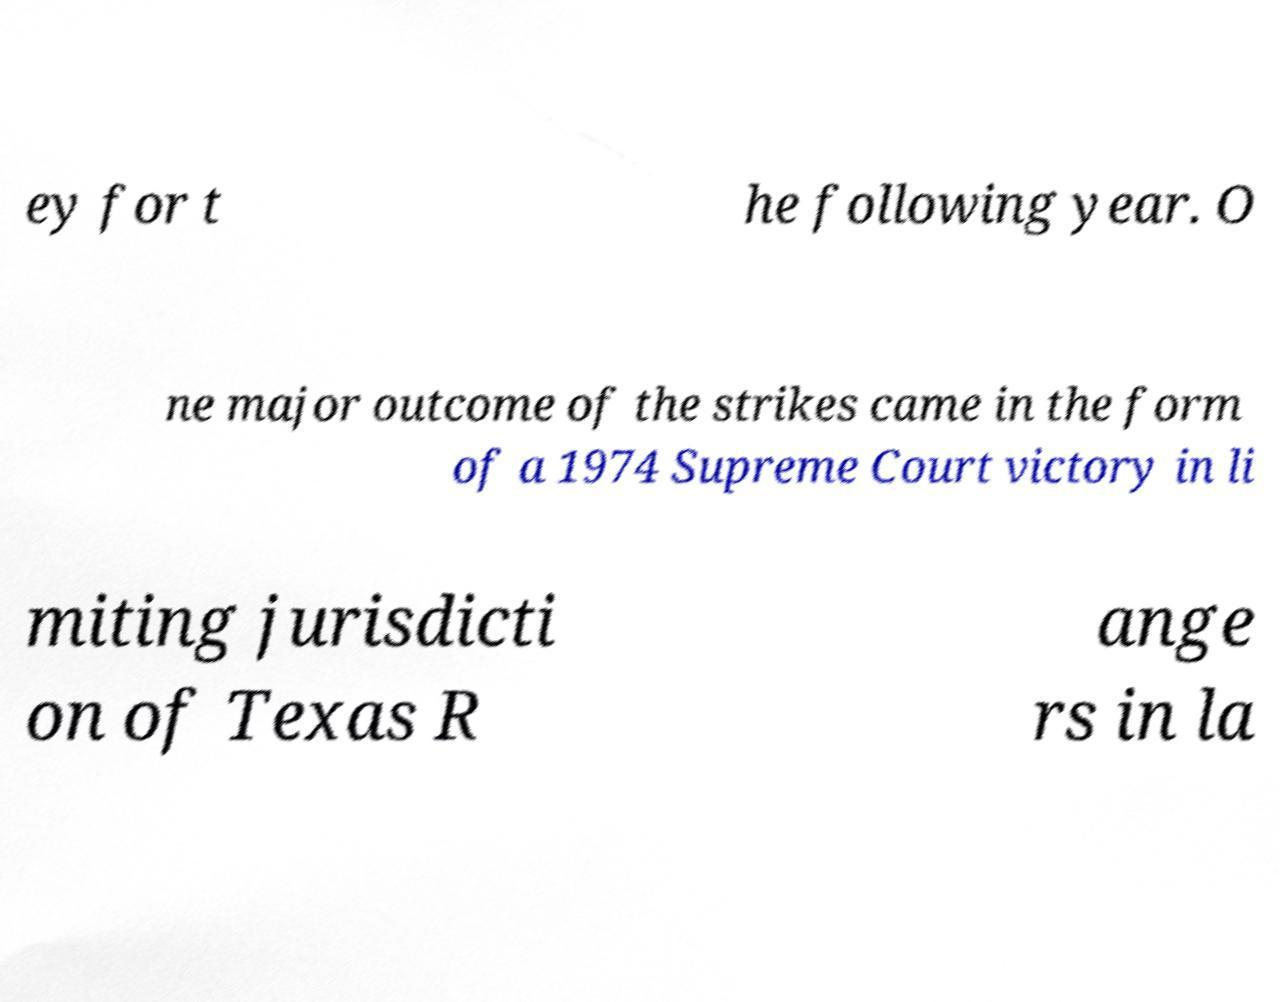What messages or text are displayed in this image? I need them in a readable, typed format. ey for t he following year. O ne major outcome of the strikes came in the form of a 1974 Supreme Court victory in li miting jurisdicti on of Texas R ange rs in la 